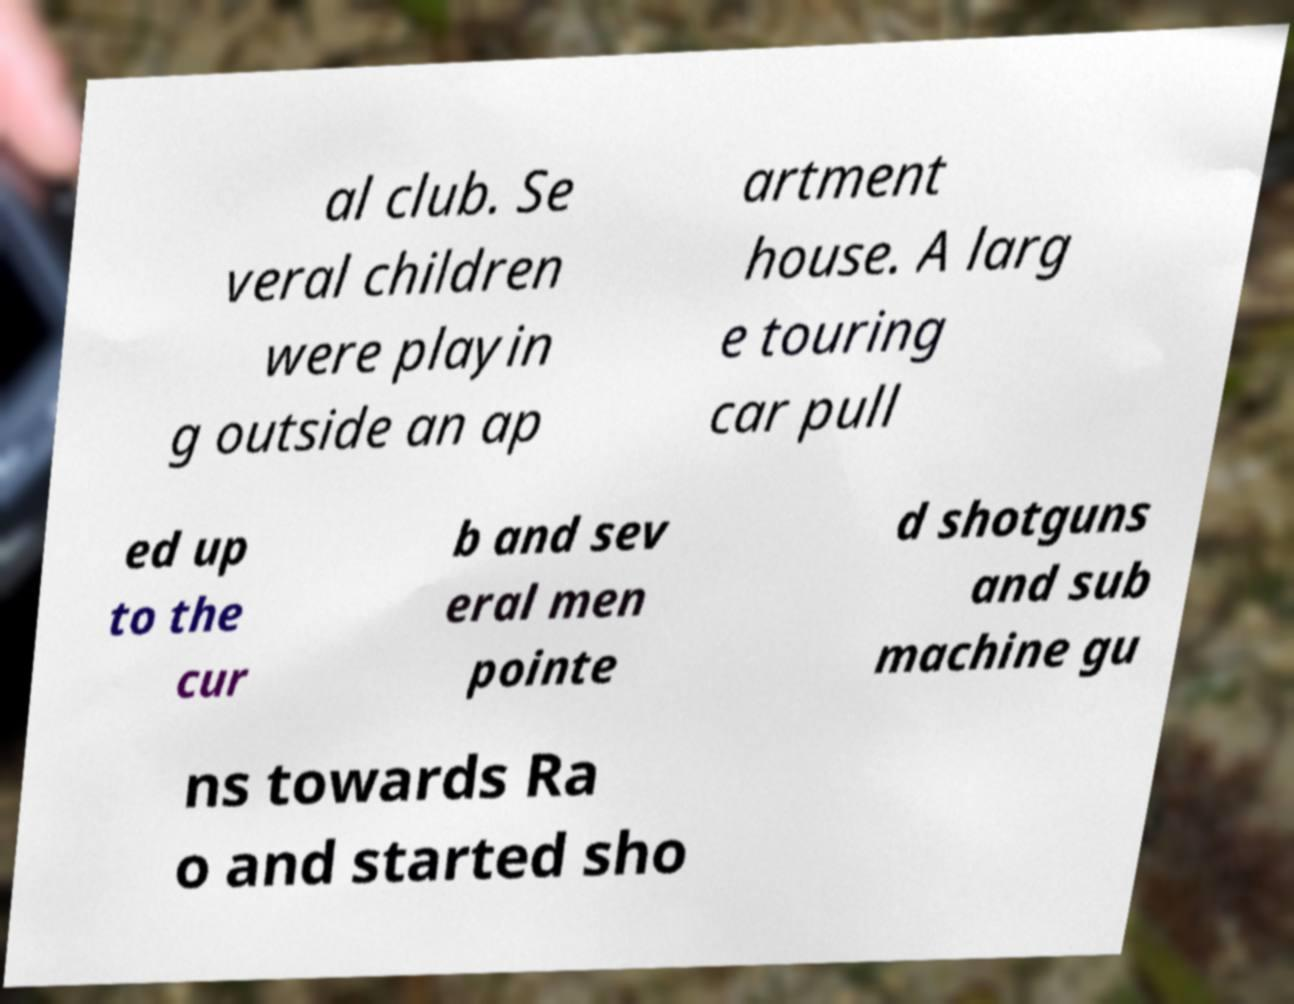Can you read and provide the text displayed in the image?This photo seems to have some interesting text. Can you extract and type it out for me? al club. Se veral children were playin g outside an ap artment house. A larg e touring car pull ed up to the cur b and sev eral men pointe d shotguns and sub machine gu ns towards Ra o and started sho 